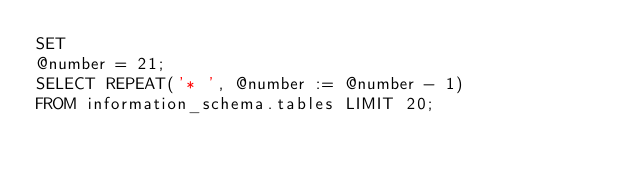<code> <loc_0><loc_0><loc_500><loc_500><_SQL_>SET
@number = 21;
SELECT REPEAT('* ', @number := @number - 1)
FROM information_schema.tables LIMIT 20;
</code> 